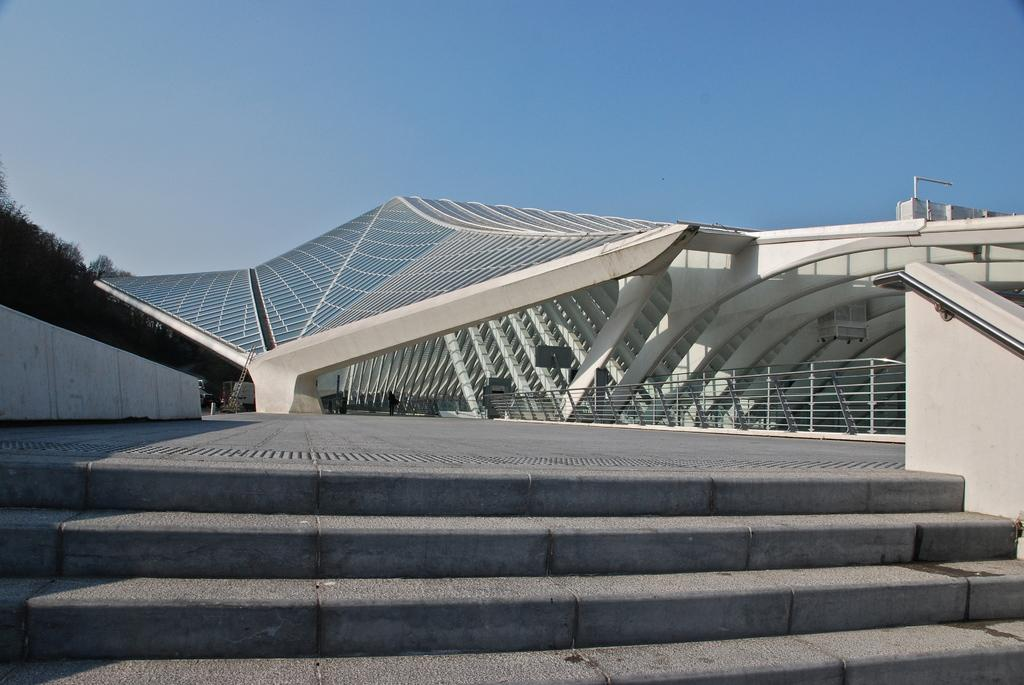What type of architectural feature can be seen in the image? There are steps and a ladder in the image. What type of enclosure is present in the image? There are fences in the image. What type of structure is visible in the image? There is a building in the image. What type of natural element is present in the image? There are trees in the image. What is the person in the image doing? There is a person on the floor in the image. What other objects can be seen in the image? There are some objects in the image. What can be seen in the background of the image? The sky is visible in the background of the image. How does the queen attract the attention of the person in the image? There is no queen present in the image, so it is not possible to answer that question. 